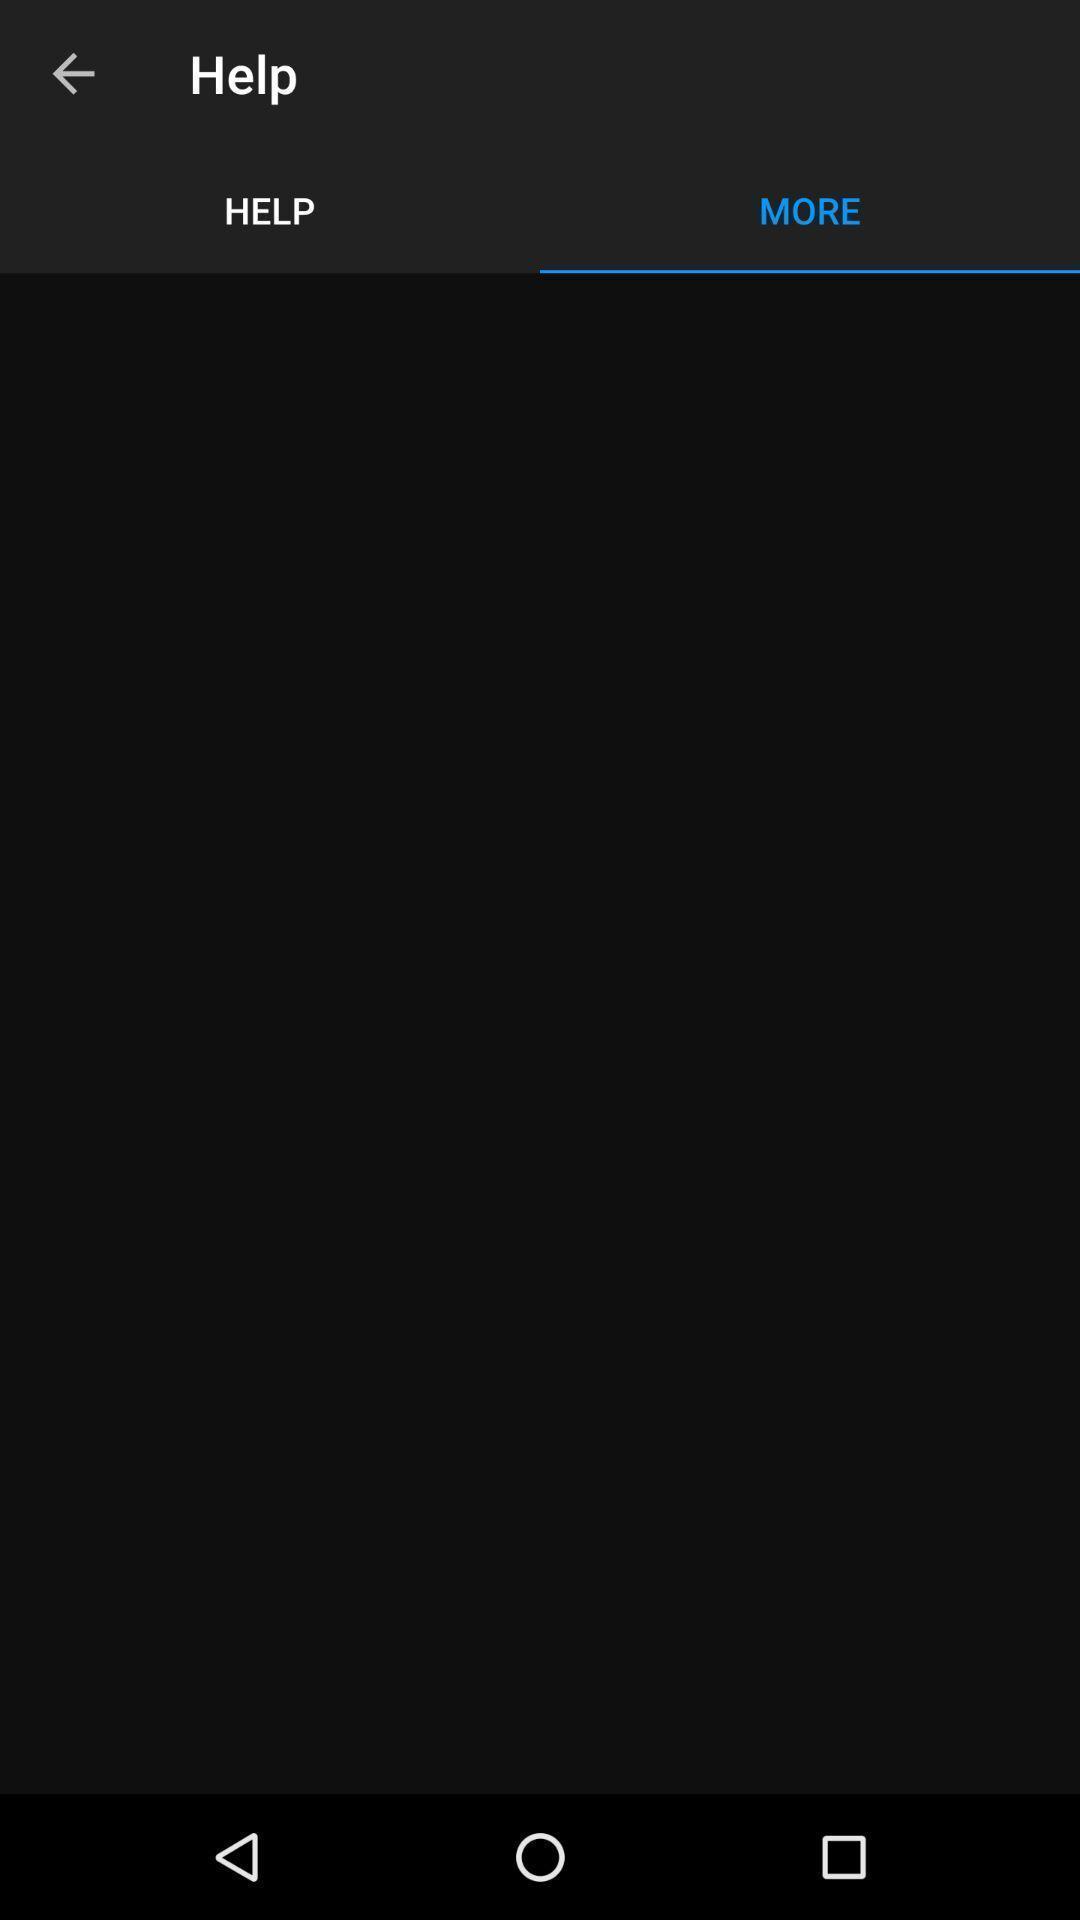Describe this image in words. Screen of mobile showing help. 